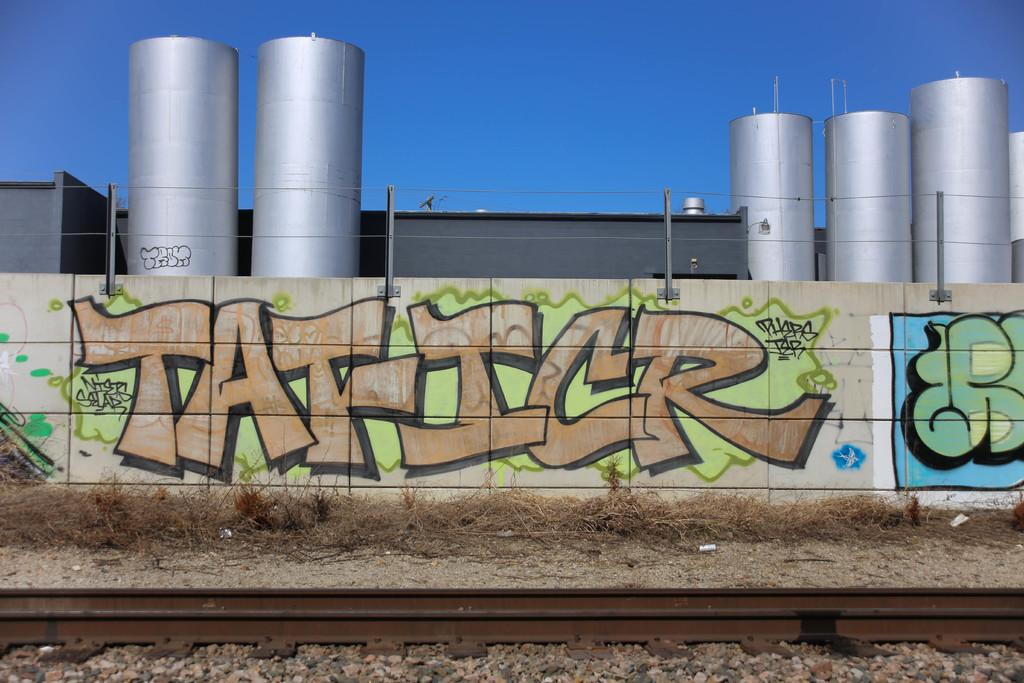What is on the wall in the image? There is graffiti on the wall in the image. What type of containers are visible in the image? There are metal jars in the image. What color is the sky in the image? The sky is blue in the image. What can be seen running through the image? There is a railway track in the image. What type of vegetation is on the ground in the image? Grass is present on the ground in the image. Where is the quiver located in the image? There is no quiver present in the image. What type of club is visible in the image? There is no club present in the image. 